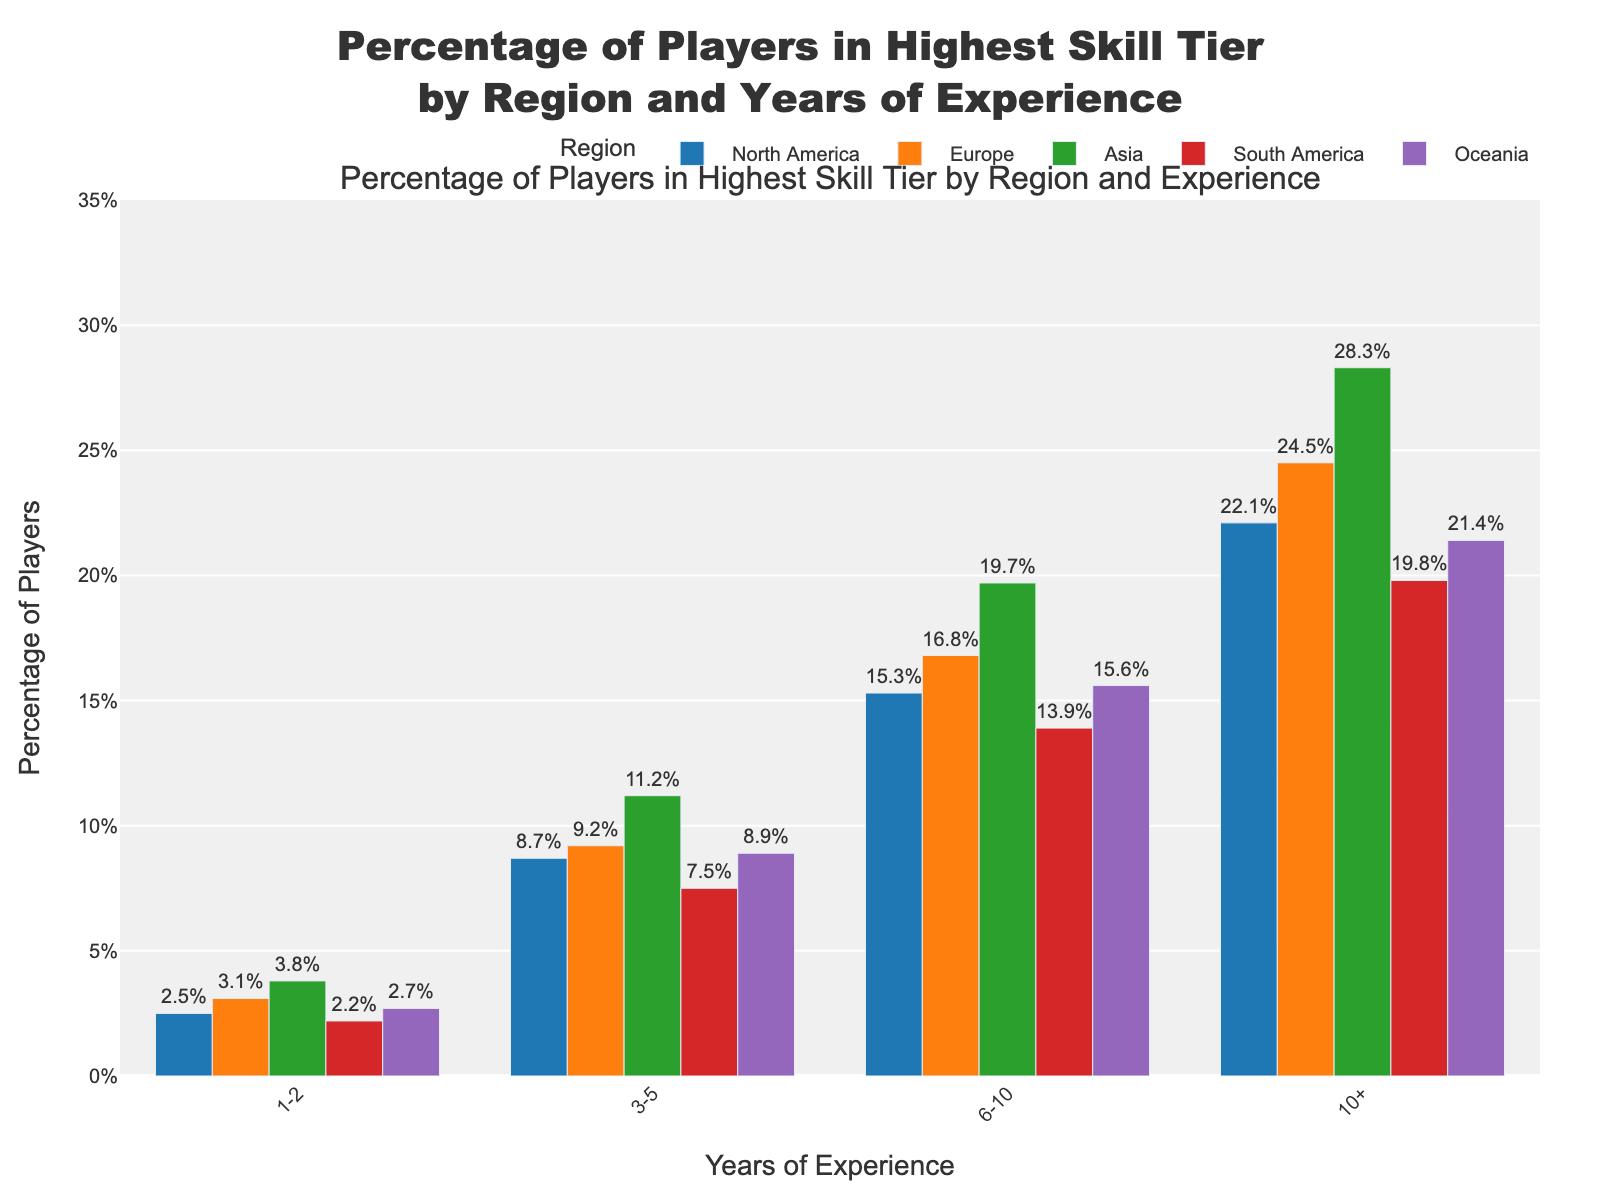What region has the highest percentage of players in the highest skill tier with 10+ years of experience? To find the region with the highest percentage of players in the highest skill tier for those with 10+ years of experience, look for the tallest bar in the "10+" years experience category. Asia has the highest bar.
Answer: Asia Which region has the smallest percentage of players in the highest skill tier with 1-2 years of experience? To determine the region with the smallest percentage of players in the highest skill tier for those with 1-2 years of experience, look for the shortest bar in the "1-2" years experience category. South America has the shortest bar.
Answer: South America What is the total percentage of players in the highest skill tier for Asia for all years of experience categories combined? Sum the percentages of players in the highest skill tier in Asia for all years of experience: 3.8 (1-2) + 11.2 (3-5) + 19.7 (6-10) + 28.3 (10+) = 63.0%.
Answer: 63.0% How does the percentage of players in North America with 6-10 years of experience compare to that in Europe with the same years of experience? Identify the "6-10" years experience bars for North America and Europe, then compare their heights. North America's bar is lower than Europe's (15.3% vs. 16.8%).
Answer: Europe has a higher percentage What is the average percentage of players in the highest skill tier in Oceania across all years of experience categories? Calculate the average by summing the percentages across all categories in Oceania and dividing by the number of categories: (2.7 + 8.9 + 15.6 + 21.4) / 4 = 12.15%.
Answer: 12.15% Which region shows a similar trend in the increase of percentages across the years of experience to Asia? Look for regions with a consistent increase in bar heights similar to Asia across "1-2", "3-5", "6-10", and "10+" years. Europe shows a similar increasing trend.
Answer: Europe By how much does the percentage of players with 3-5 years of experience in South America differ from that in North America? Subtract the percentage of South America from North America for the "3-5" years experience category: 8.7% - 7.5% = 1.2%.
Answer: 1.2% Which region has the most significant difference between the highest and lowest percentage of players in the highest skill tier across different years of experience? Calculate the differences between highest and lowest percentages across all categories for each region: 
North America (22.1 - 2.5 = 19.6), 
Europe (24.5 - 3.1 = 21.4), 
Asia (28.3 - 3.8 = 24.5), 
South America (19.8 - 2.2 = 17.6), 
Oceania (21.4 - 2.7 = 18.7). 
Asia has the largest difference.
Answer: Asia 